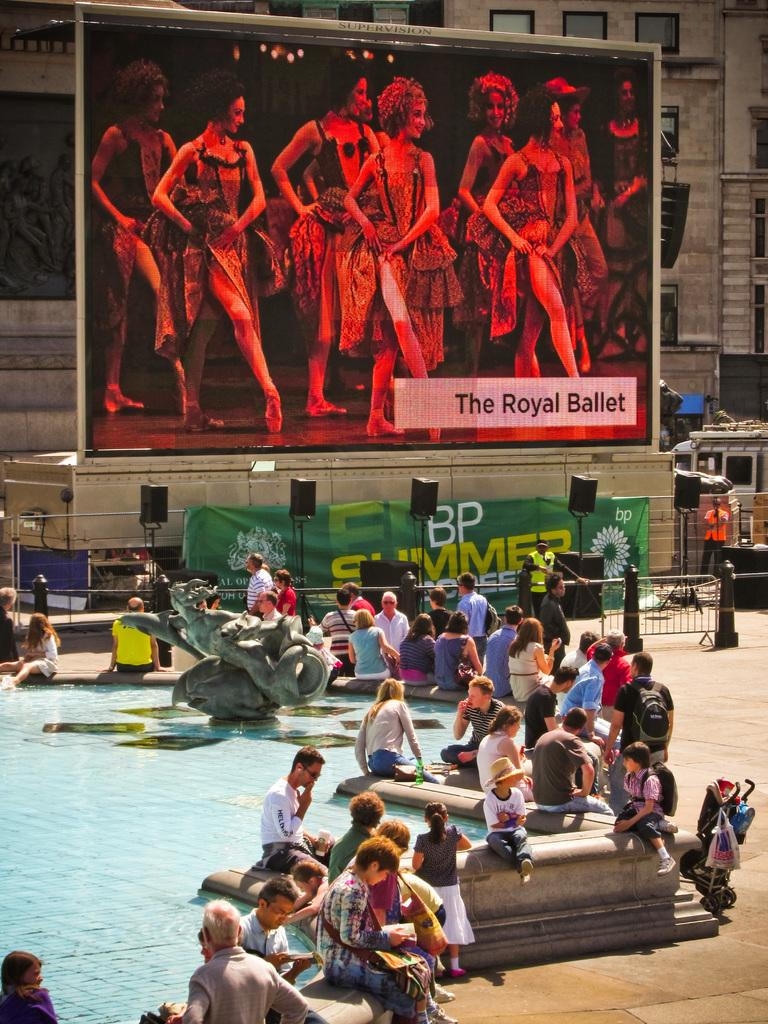How many people are in the image? There is a group of people in the image. What is the primary element visible in the image? There is water visible in the image. What type of artwork can be seen in the image? There is a sculpture in the image. What can be seen in the background of the image? There are hoardings and speakers in the background of the image. What type of windows are on the building in the image? The building has glass windows. Can you tell me how many toes the dog has in the image? There is no dog present in the image, so it is not possible to determine the number of toes. 